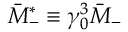<formula> <loc_0><loc_0><loc_500><loc_500>\bar { M } _ { - } ^ { \ast } \equiv \gamma _ { 0 } ^ { 3 } \bar { M } _ { - }</formula> 